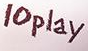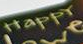What text is displayed in these images sequentially, separated by a semicolon? 10play; HappY 